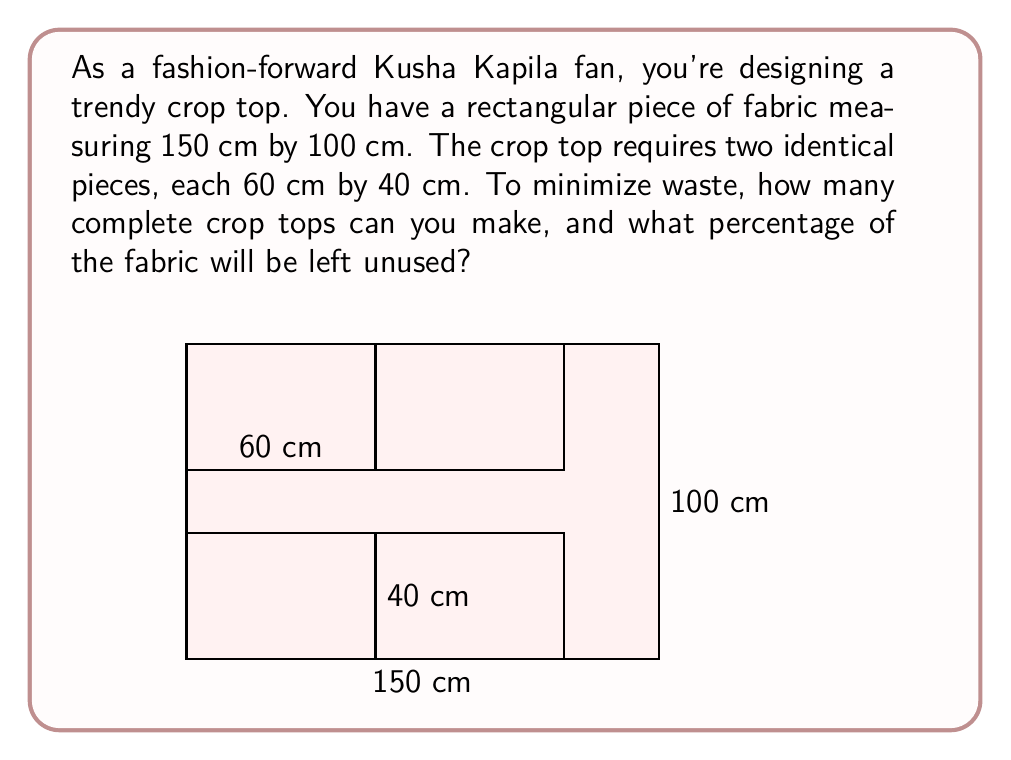Teach me how to tackle this problem. Let's approach this step-by-step:

1) First, calculate the total area of the fabric:
   $A_{total} = 150 \text{ cm} \times 100 \text{ cm} = 15,000 \text{ cm}^2$

2) Calculate the area needed for one crop top piece:
   $A_{piece} = 60 \text{ cm} \times 40 \text{ cm} = 2,400 \text{ cm}^2$

3) Since each crop top requires two pieces, the area needed for one complete crop top is:
   $A_{crop top} = 2 \times 2,400 \text{ cm}^2 = 4,800 \text{ cm}^2$

4) To find how many crop tops can be made, divide the total area by the area needed for one crop top:
   $N_{crop tops} = \frac{A_{total}}{A_{crop top}} = \frac{15,000}{4,800} = 3.125$

   Since we can only make whole crop tops, we round down to 3.

5) Calculate the area used for 3 crop tops:
   $A_{used} = 3 \times 4,800 \text{ cm}^2 = 14,400 \text{ cm}^2$

6) Calculate the unused area:
   $A_{unused} = A_{total} - A_{used} = 15,000 \text{ cm}^2 - 14,400 \text{ cm}^2 = 600 \text{ cm}^2$

7) Calculate the percentage of unused fabric:
   $\text{Percentage unused} = \frac{A_{unused}}{A_{total}} \times 100\% = \frac{600}{15,000} \times 100\% = 4\%$

Therefore, you can make 3 complete crop tops, and 4% of the fabric will be left unused.
Answer: 3 crop tops; 4% unused 